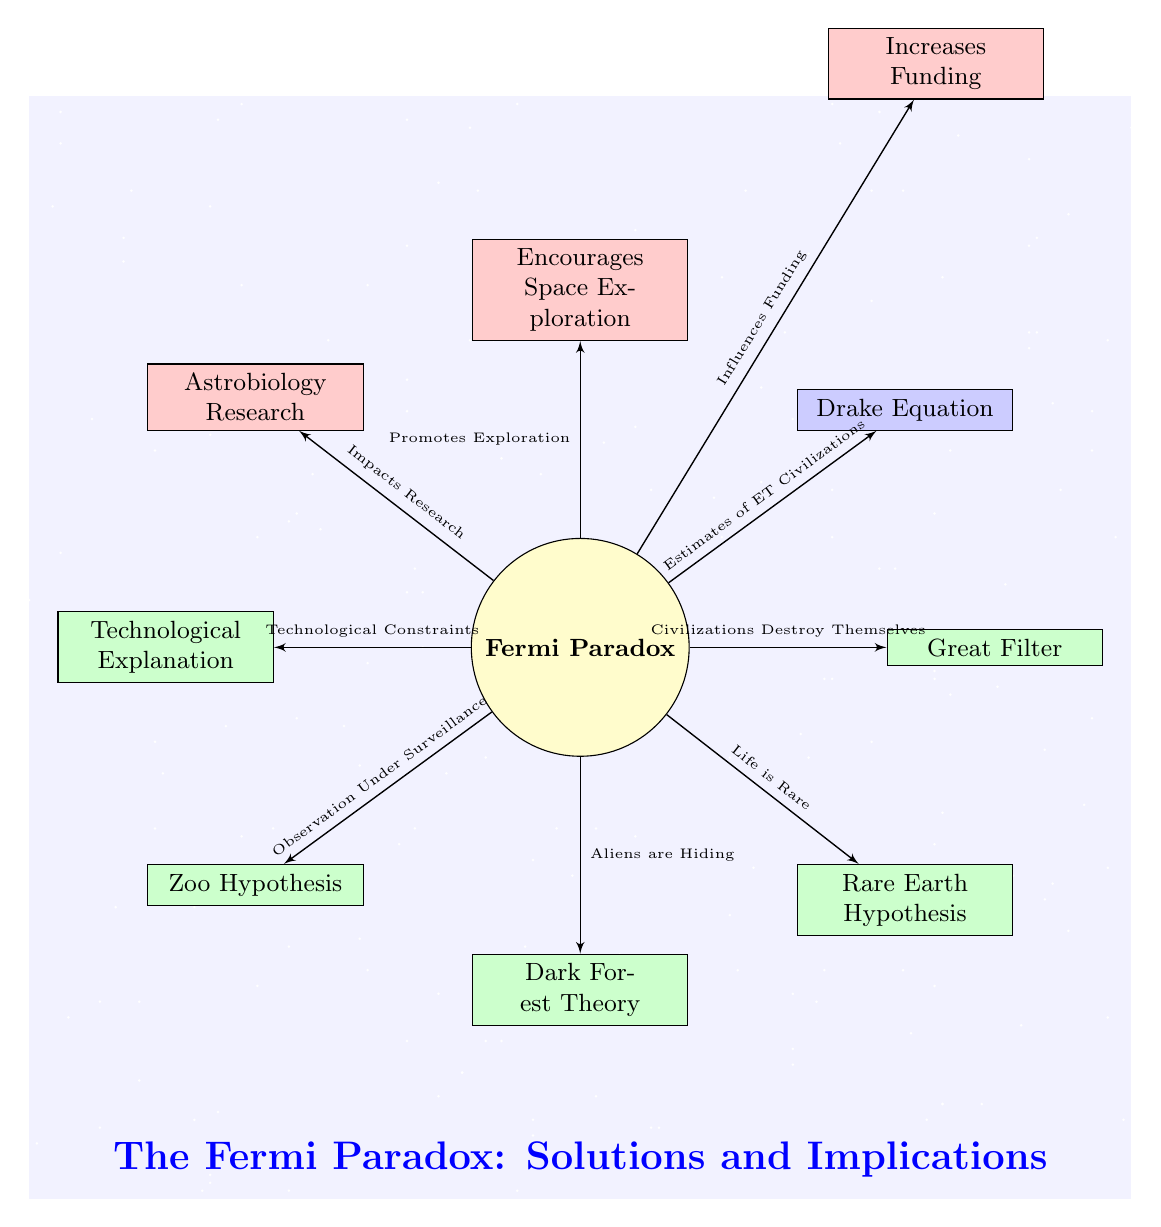What is the central concept of the diagram? The diagram centers around the "Fermi Paradox," which is displayed prominently in the central node. The term is visually emphasized by its placement and color.
Answer: Fermi Paradox How many solution nodes are present in the diagram? There are five solution nodes branching out from the Fermi Paradox node, namely Great Filter, Rare Earth Hypothesis, Dark Forest Theory, Zoo Hypothesis, and Technological Explanation.
Answer: Five What type of node is the "Drake Equation"? The "Drake Equation" is positioned above right of the central "Fermi Paradox" node and is categorized as a factor node, indicated by its rectangle shape and blue color.
Answer: Factor Which implication node is linked to the concept of funding? The implication node labeled "Increases Funding" is connected to the "Encourages Space Exploration" node, which stems from the "Fermi Paradox."
Answer: Increases Funding What is the relationship between the Great Filter and the Fermi Paradox? The diagram shows a direct edge from the Fermi Paradox node to the Great Filter node, labeled "Civilizations Destroy Themselves." This implies that the Great Filter provides an explanation related to the Fermi Paradox.
Answer: Civilizations Destroy Themselves How does the "Drake Equation" relate to extraterrestrial civilizations? The edge labeled "Estimates of ET Civilizations" connects the "Drake Equation" node to the central Fermi Paradox, indicating that the Drake Equation is a mathematical framework to estimate the number of extraterrestrial civilizations.
Answer: Estimates of ET Civilizations Which hypothesis suggests aliens are concealing their existence? The hypothesis referred to in the diagram that suggests aliens are purposely hiding from us is the "Dark Forest Theory," indicated by its direct connection to the Fermi Paradox node.
Answer: Dark Forest Theory What effect does the Fermi Paradox have on astrobiology research? The diagram illustrates an edge from the Fermi Paradox node to the "Astrobiology Research" implication, showing that the paradox impacts ongoing research efforts in astrobiology.
Answer: Impacts Research 